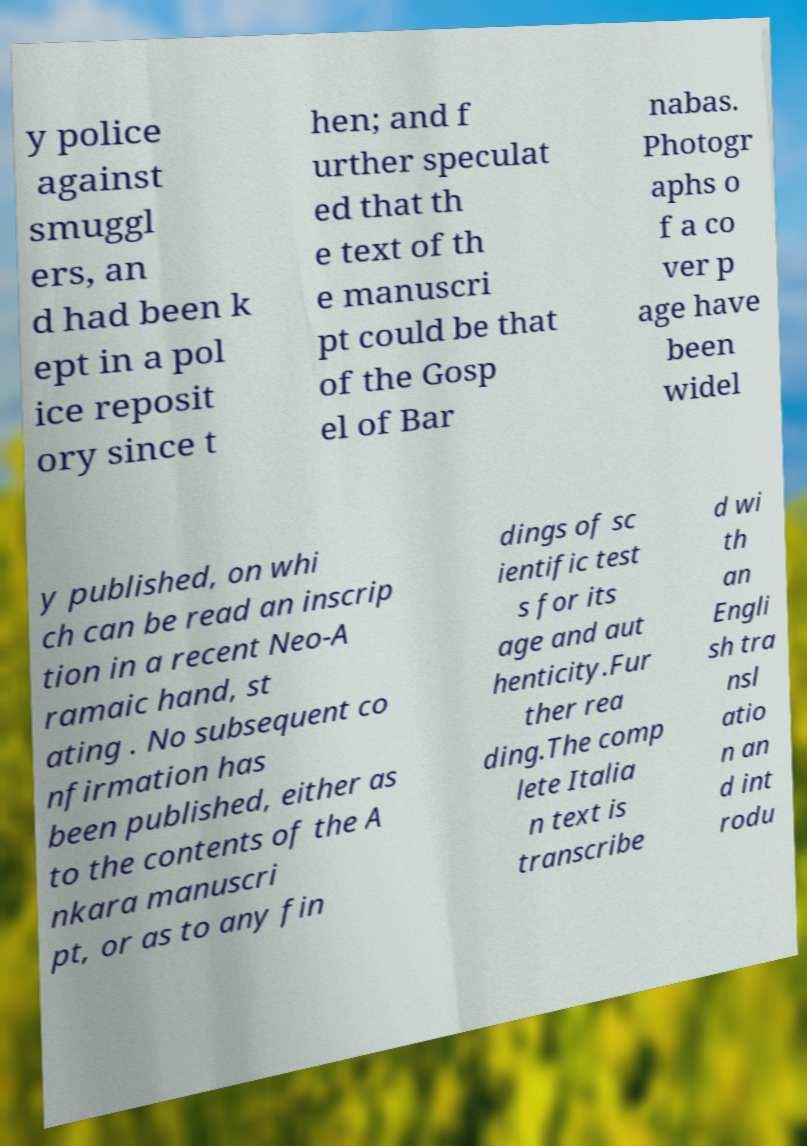Can you accurately transcribe the text from the provided image for me? y police against smuggl ers, an d had been k ept in a pol ice reposit ory since t hen; and f urther speculat ed that th e text of th e manuscri pt could be that of the Gosp el of Bar nabas. Photogr aphs o f a co ver p age have been widel y published, on whi ch can be read an inscrip tion in a recent Neo-A ramaic hand, st ating . No subsequent co nfirmation has been published, either as to the contents of the A nkara manuscri pt, or as to any fin dings of sc ientific test s for its age and aut henticity.Fur ther rea ding.The comp lete Italia n text is transcribe d wi th an Engli sh tra nsl atio n an d int rodu 